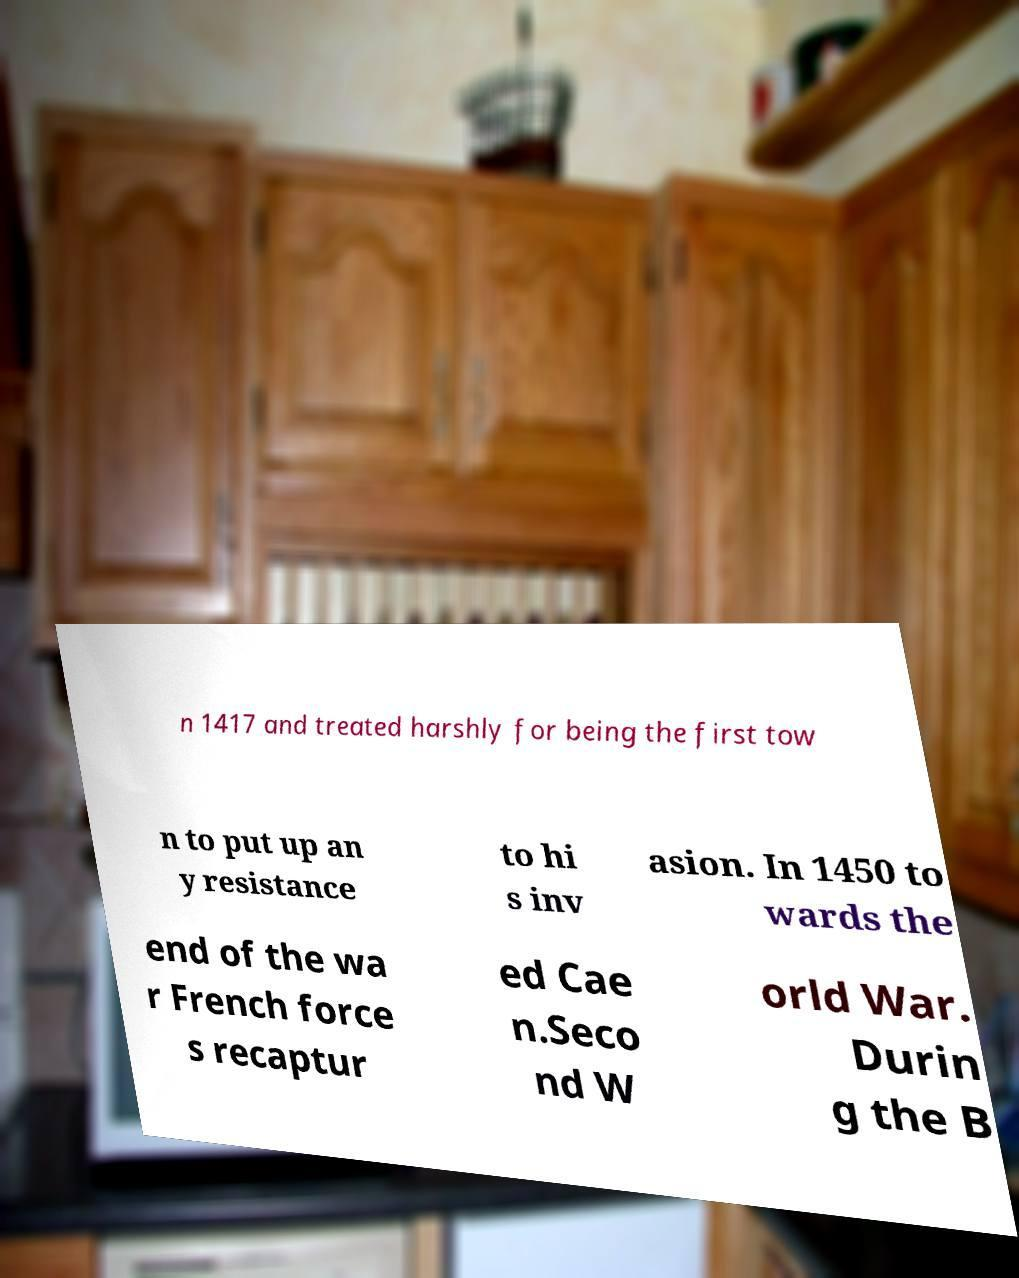Can you accurately transcribe the text from the provided image for me? n 1417 and treated harshly for being the first tow n to put up an y resistance to hi s inv asion. In 1450 to wards the end of the wa r French force s recaptur ed Cae n.Seco nd W orld War. Durin g the B 